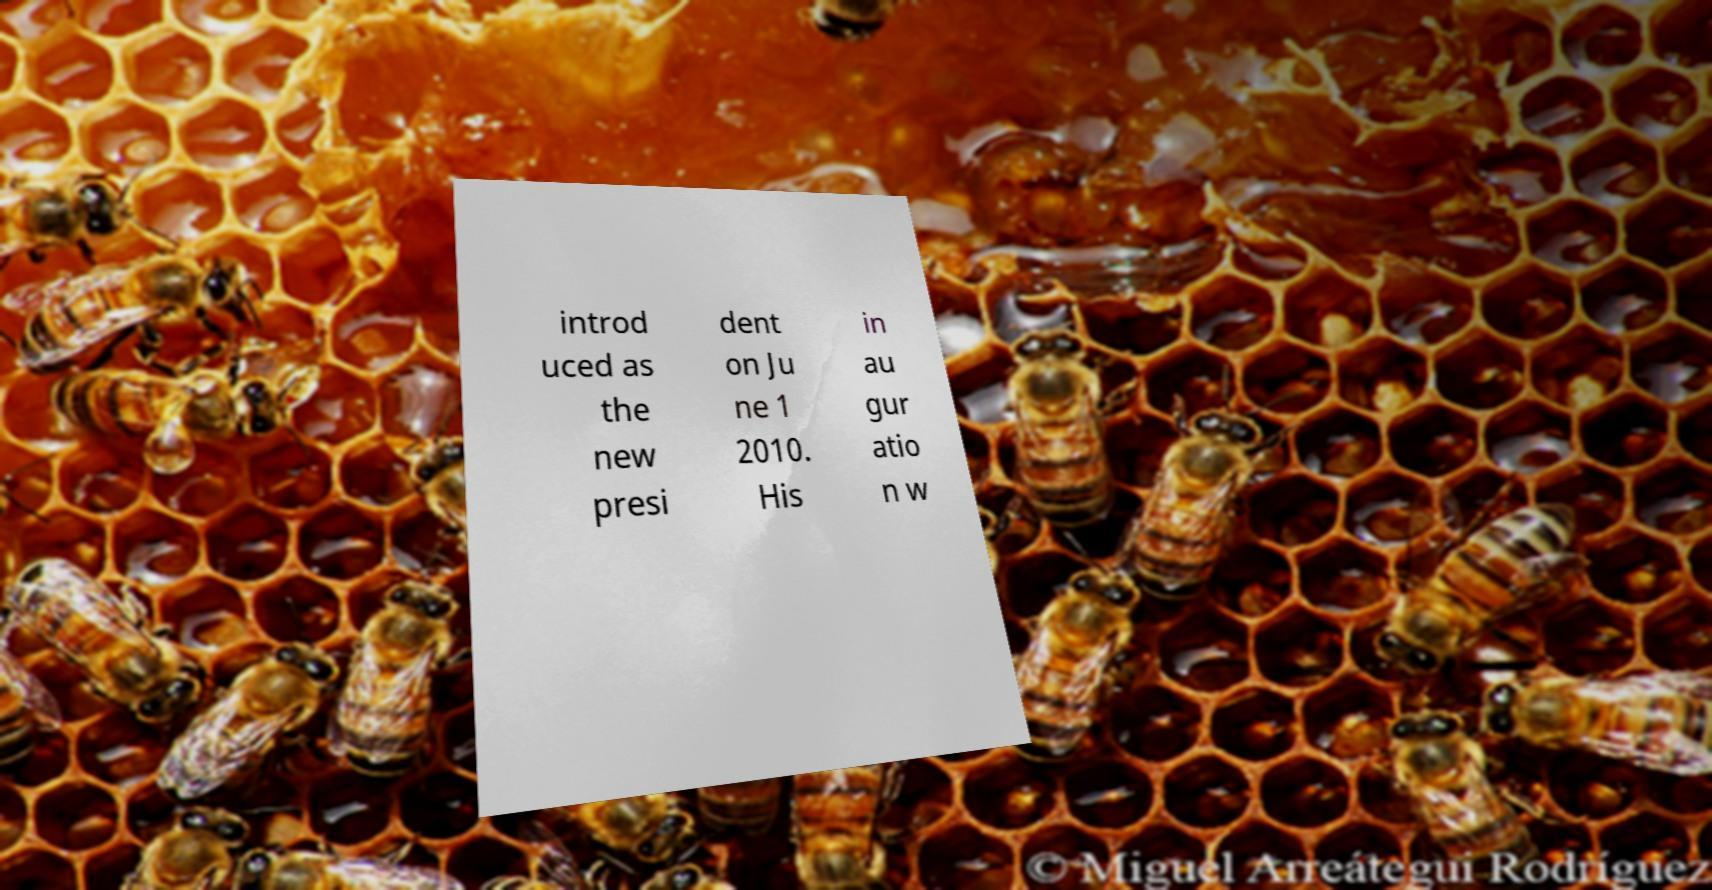There's text embedded in this image that I need extracted. Can you transcribe it verbatim? introd uced as the new presi dent on Ju ne 1 2010. His in au gur atio n w 